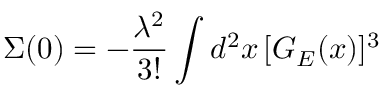<formula> <loc_0><loc_0><loc_500><loc_500>\Sigma ( 0 ) = - \frac { { \lambda } ^ { 2 } } { 3 ! } \int d ^ { 2 } x \, [ G _ { E } ( x ) ] ^ { 3 }</formula> 